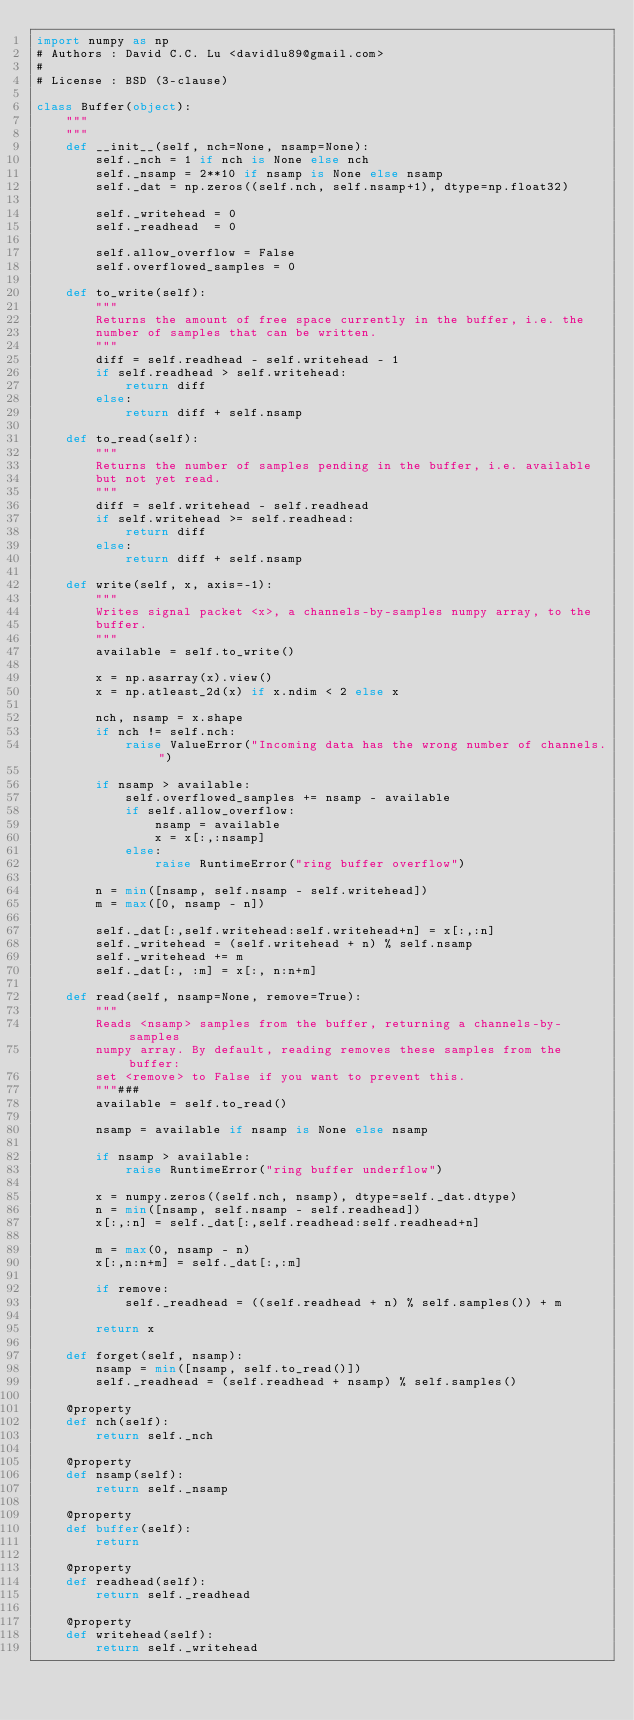<code> <loc_0><loc_0><loc_500><loc_500><_Python_>import numpy as np
# Authors : David C.C. Lu <davidlu89@gmail.com>
#
# License : BSD (3-clause)

class Buffer(object):
    """
    """
    def __init__(self, nch=None, nsamp=None):
        self._nch = 1 if nch is None else nch
        self._nsamp = 2**10 if nsamp is None else nsamp
        self._dat = np.zeros((self.nch, self.nsamp+1), dtype=np.float32)

        self._writehead = 0
        self._readhead  = 0

        self.allow_overflow = False
        self.overflowed_samples = 0

    def to_write(self):
        """
        Returns the amount of free space currently in the buffer, i.e. the
        number of samples that can be written.
        """
        diff = self.readhead - self.writehead - 1
        if self.readhead > self.writehead:
            return diff
        else:
            return diff + self.nsamp

    def to_read(self):
        """
        Returns the number of samples pending in the buffer, i.e. available
        but not yet read.
        """
        diff = self.writehead - self.readhead
        if self.writehead >= self.readhead:
            return diff
        else:
            return diff + self.nsamp

    def write(self, x, axis=-1):
        """
        Writes signal packet <x>, a channels-by-samples numpy array, to the
        buffer.
        """
        available = self.to_write()

        x = np.asarray(x).view()
        x = np.atleast_2d(x) if x.ndim < 2 else x

        nch, nsamp = x.shape
        if nch != self.nch:
            raise ValueError("Incoming data has the wrong number of channels.")

        if nsamp > available:
            self.overflowed_samples += nsamp - available
            if self.allow_overflow:
                nsamp = available
                x = x[:,:nsamp]
            else:
                raise RuntimeError("ring buffer overflow")

        n = min([nsamp, self.nsamp - self.writehead])
        m = max([0, nsamp - n])

        self._dat[:,self.writehead:self.writehead+n] = x[:,:n]
        self._writehead = (self.writehead + n) % self.nsamp
        self._writehead += m
        self._dat[:, :m] = x[:, n:n+m]

    def read(self, nsamp=None, remove=True):
        """
        Reads <nsamp> samples from the buffer, returning a channels-by-samples
        numpy array. By default, reading removes these samples from the buffer:
        set <remove> to False if you want to prevent this.
        """###
        available = self.to_read()

        nsamp = available if nsamp is None else nsamp

        if nsamp > available:
            raise RuntimeError("ring buffer underflow")

        x = numpy.zeros((self.nch, nsamp), dtype=self._dat.dtype)
        n = min([nsamp, self.nsamp - self.readhead])
        x[:,:n] = self._dat[:,self.readhead:self.readhead+n]

        m = max(0, nsamp - n)
        x[:,n:n+m] = self._dat[:,:m]

        if remove:
            self._readhead = ((self.readhead + n) % self.samples()) + m

        return x

    def forget(self, nsamp):
        nsamp = min([nsamp, self.to_read()])
        self._readhead = (self.readhead + nsamp) % self.samples()

    @property
    def nch(self):
        return self._nch

    @property
    def nsamp(self):
        return self._nsamp

    @property
    def buffer(self):
        return

    @property
    def readhead(self):
        return self._readhead

    @property
    def writehead(self):
        return self._writehead
</code> 